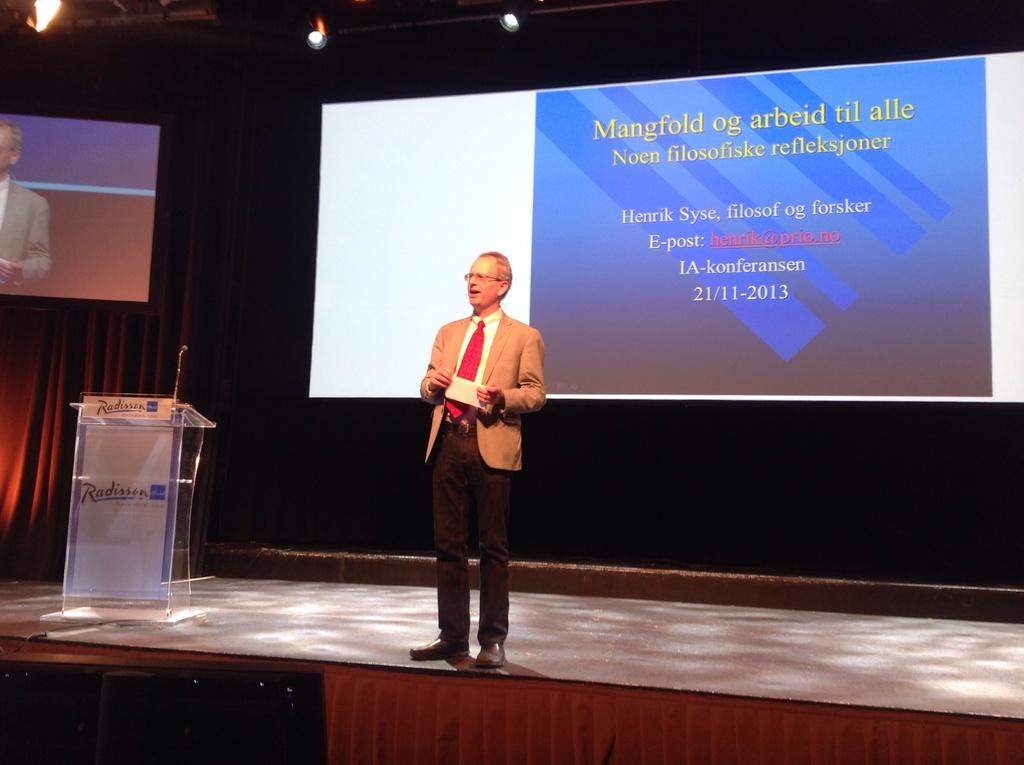<image>
Give a short and clear explanation of the subsequent image. A man is standing on a stage with 21/11-2013 on background behind him. 